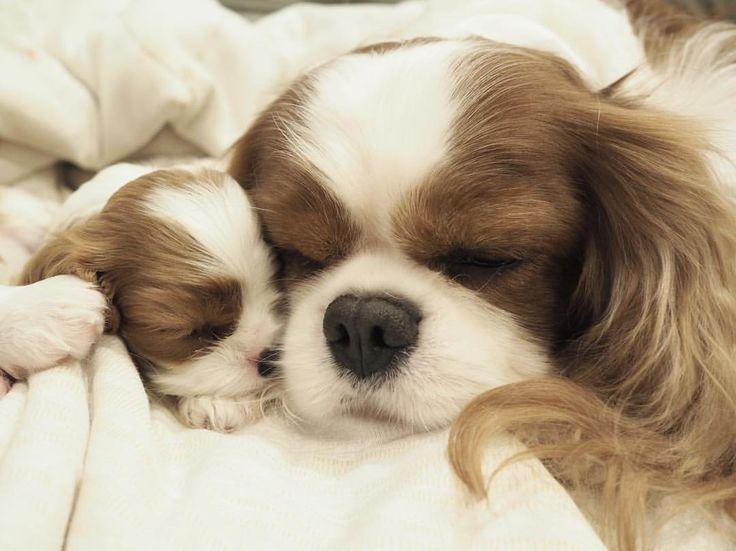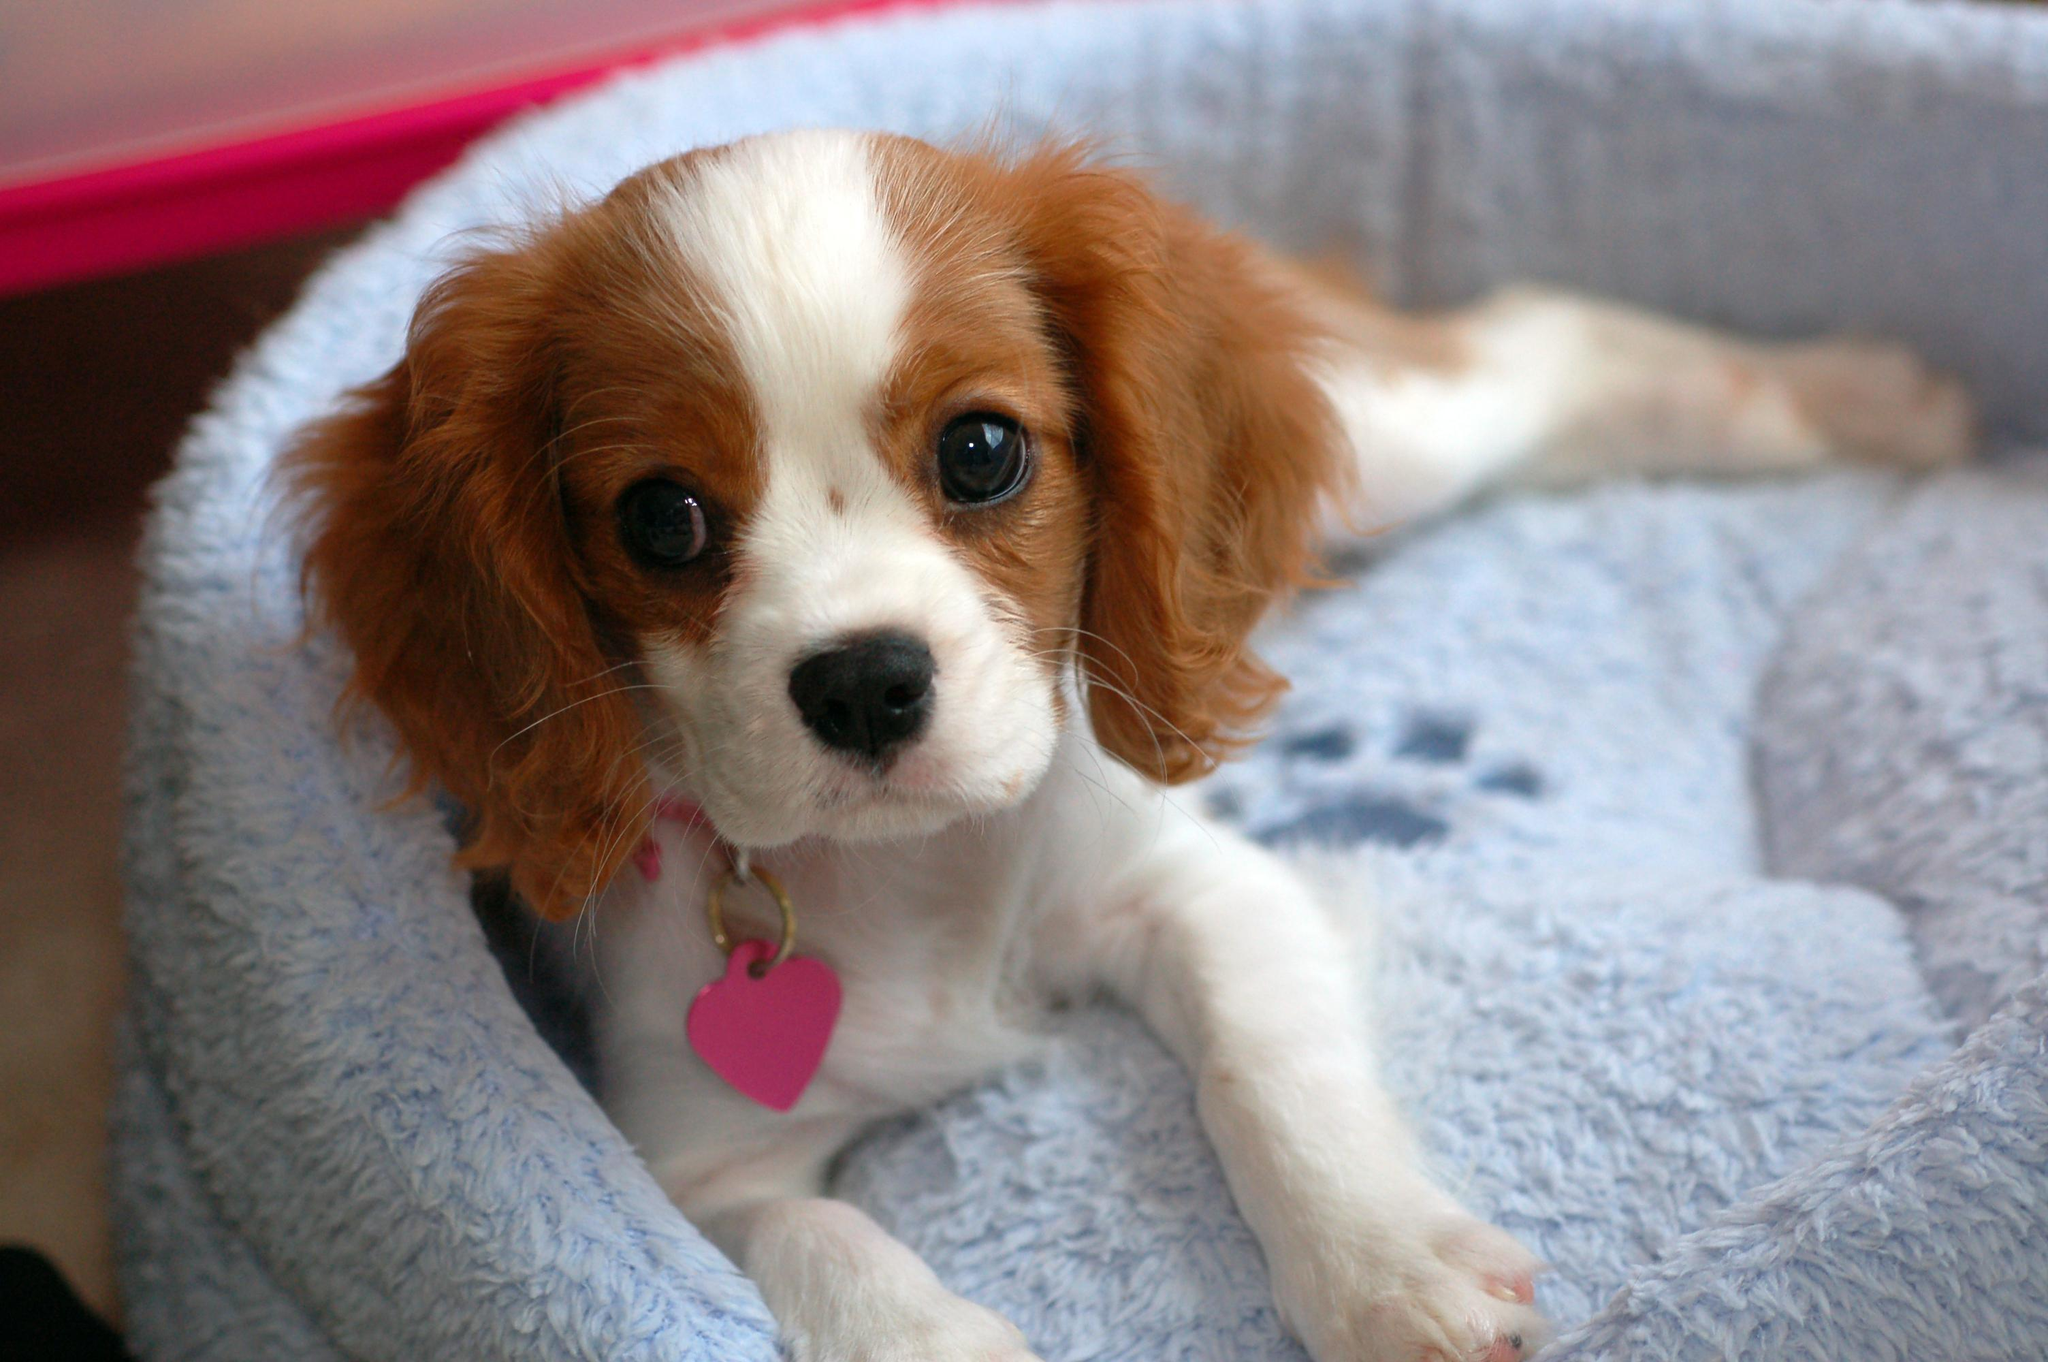The first image is the image on the left, the second image is the image on the right. Evaluate the accuracy of this statement regarding the images: "One image shows a spaniel puppy inside a soft-sided pet bed, with its head upright instead of draped over the edge.". Is it true? Answer yes or no. Yes. The first image is the image on the left, the second image is the image on the right. For the images displayed, is the sentence "The dog in the image on the right is lying down." factually correct? Answer yes or no. Yes. 